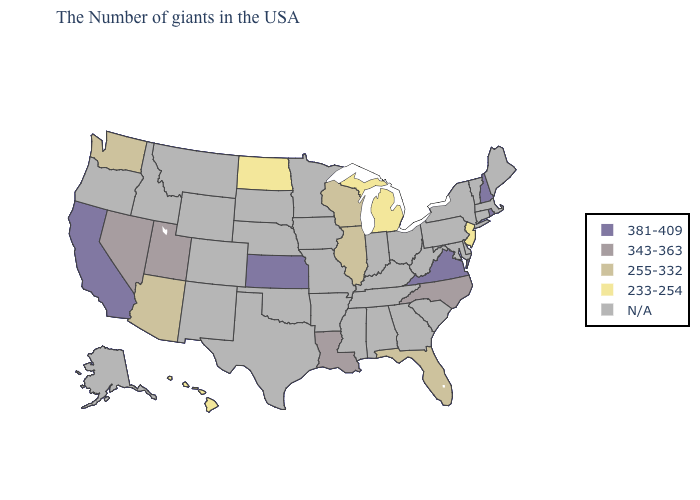What is the value of Illinois?
Quick response, please. 255-332. Does the first symbol in the legend represent the smallest category?
Give a very brief answer. No. What is the lowest value in states that border Nebraska?
Keep it brief. 381-409. Does Virginia have the highest value in the South?
Concise answer only. Yes. Among the states that border West Virginia , which have the lowest value?
Concise answer only. Virginia. Is the legend a continuous bar?
Keep it brief. No. Among the states that border Colorado , which have the highest value?
Answer briefly. Kansas. Name the states that have a value in the range 381-409?
Write a very short answer. Rhode Island, New Hampshire, Virginia, Kansas, California. What is the value of New Jersey?
Concise answer only. 233-254. How many symbols are there in the legend?
Concise answer only. 5. What is the highest value in states that border Nebraska?
Be succinct. 381-409. Name the states that have a value in the range N/A?
Keep it brief. Maine, Massachusetts, Vermont, Connecticut, New York, Delaware, Maryland, Pennsylvania, South Carolina, West Virginia, Ohio, Georgia, Kentucky, Indiana, Alabama, Tennessee, Mississippi, Missouri, Arkansas, Minnesota, Iowa, Nebraska, Oklahoma, Texas, South Dakota, Wyoming, Colorado, New Mexico, Montana, Idaho, Oregon, Alaska. Does the map have missing data?
Quick response, please. Yes. Does the map have missing data?
Short answer required. Yes. 